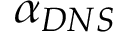<formula> <loc_0><loc_0><loc_500><loc_500>\alpha _ { D N S }</formula> 